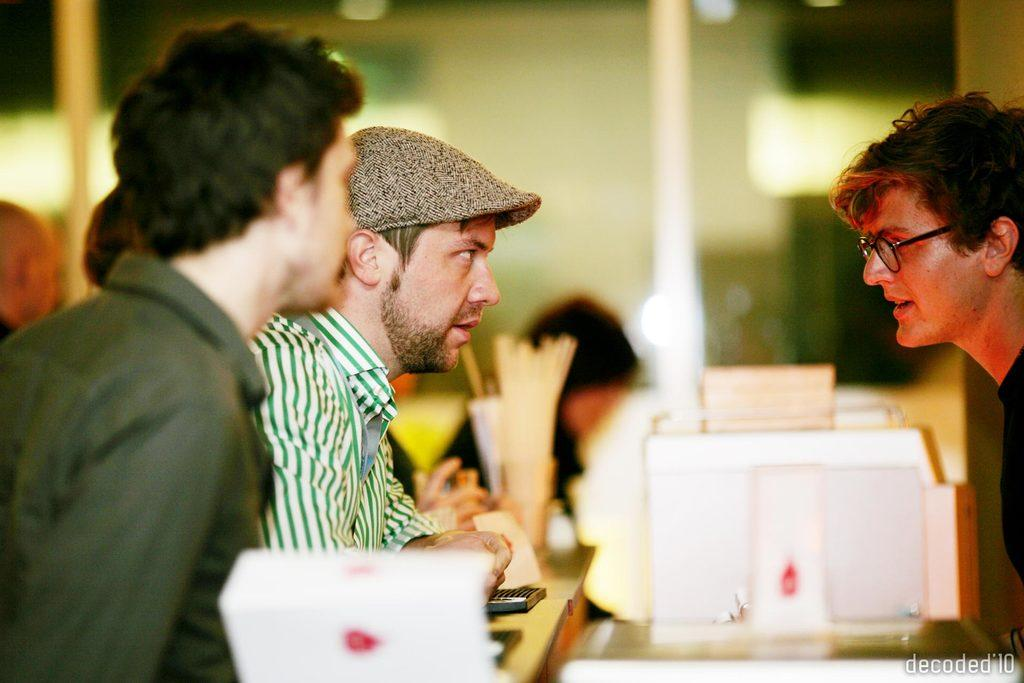How many people are in the image? A: There are three men in the image. What are the men doing in the image? The men are talking to each other. Where is the man on the right side of the image located? The man on the right side of the image is on the right side. How are the remaining two men positioned in relation to the man on the right side? The remaining two men are opposite to the man on the right side. Can you describe the background of the image? The background of the image is blurry. What type of leaf is being used as a platform for the men's ideas in the image? There is no leaf present in the image, and the men are not using any platform for their ideas. 